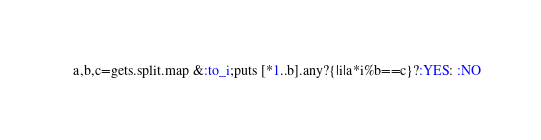Convert code to text. <code><loc_0><loc_0><loc_500><loc_500><_Ruby_>a,b,c=gets.split.map &:to_i;puts [*1..b].any?{|i|a*i%b==c}?:YES: :NO</code> 